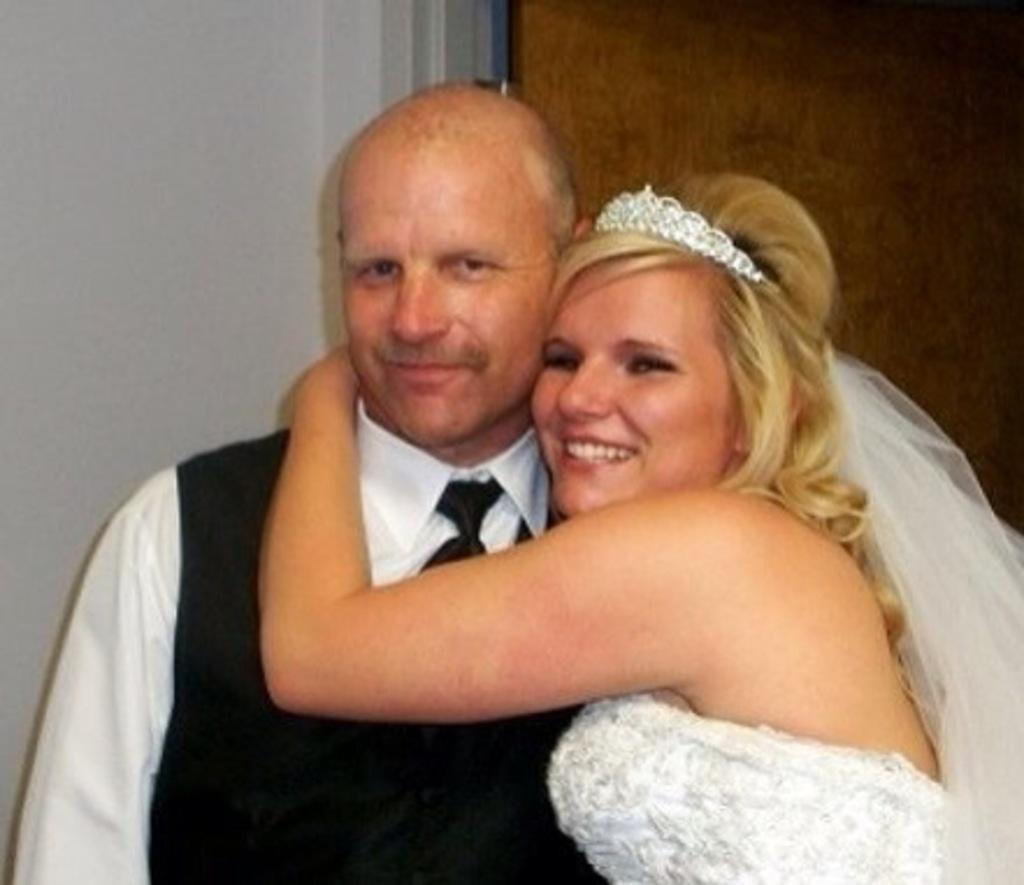How would you summarize this image in a sentence or two? In this image I can see two people standing and wearing black and white color dresses. She is wearing white color crown. Back I can see the white wall. 